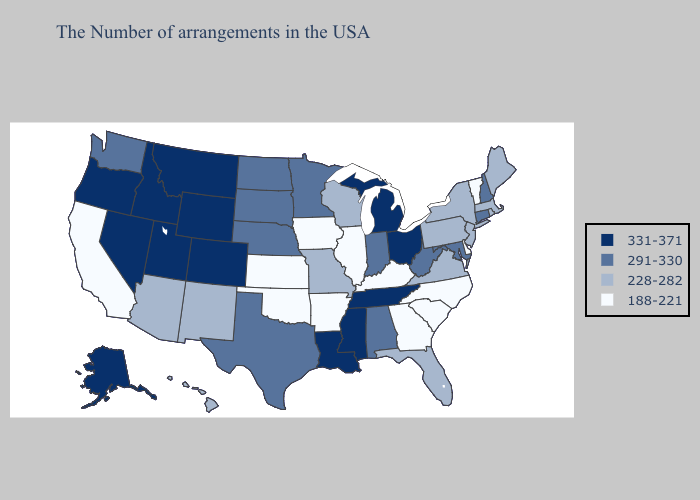Does Pennsylvania have a lower value than Minnesota?
Short answer required. Yes. What is the highest value in states that border Missouri?
Write a very short answer. 331-371. What is the highest value in states that border Wyoming?
Short answer required. 331-371. Does Virginia have the highest value in the USA?
Write a very short answer. No. Does the first symbol in the legend represent the smallest category?
Quick response, please. No. Does the map have missing data?
Answer briefly. No. Among the states that border Georgia , does Alabama have the lowest value?
Give a very brief answer. No. What is the value of Oregon?
Keep it brief. 331-371. Does Nevada have a higher value than Utah?
Answer briefly. No. What is the highest value in the USA?
Be succinct. 331-371. What is the highest value in the USA?
Answer briefly. 331-371. Does Florida have a higher value than Wisconsin?
Concise answer only. No. Among the states that border California , which have the highest value?
Quick response, please. Nevada, Oregon. What is the value of Maine?
Write a very short answer. 228-282. 